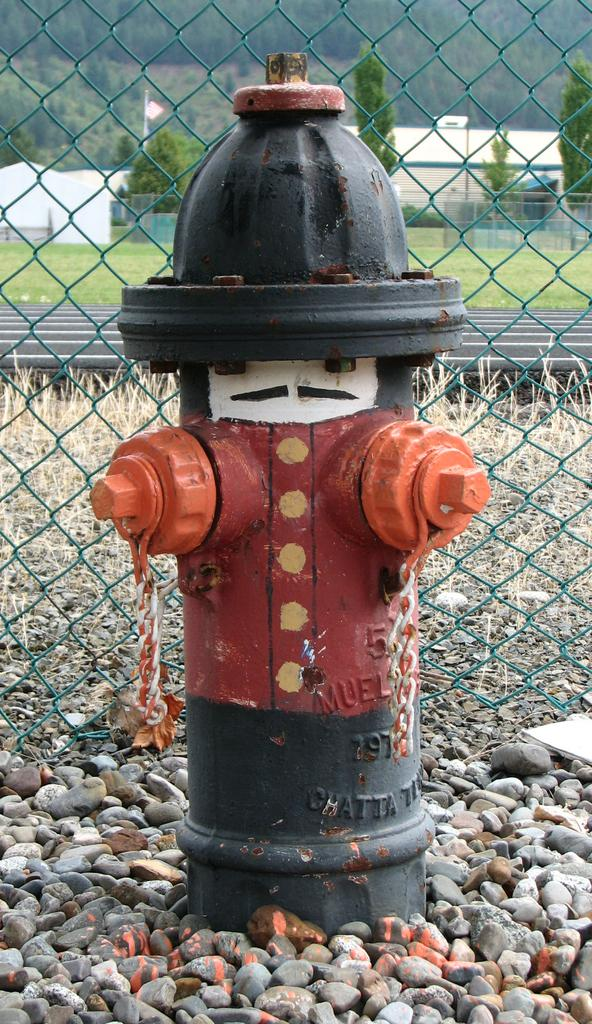What object is on the ground in the image? There is a hydrant on the ground in the image. What type of natural elements can be seen in the image? There are stones visible in the image. What structures are visible in the background of the image? There is a fence, poles, trees, posters, and sheds in the background of the image. What type of lead can be seen in the image? There is no lead present in the image. Is there a camp visible in the image? There is no camp visible in the image. 